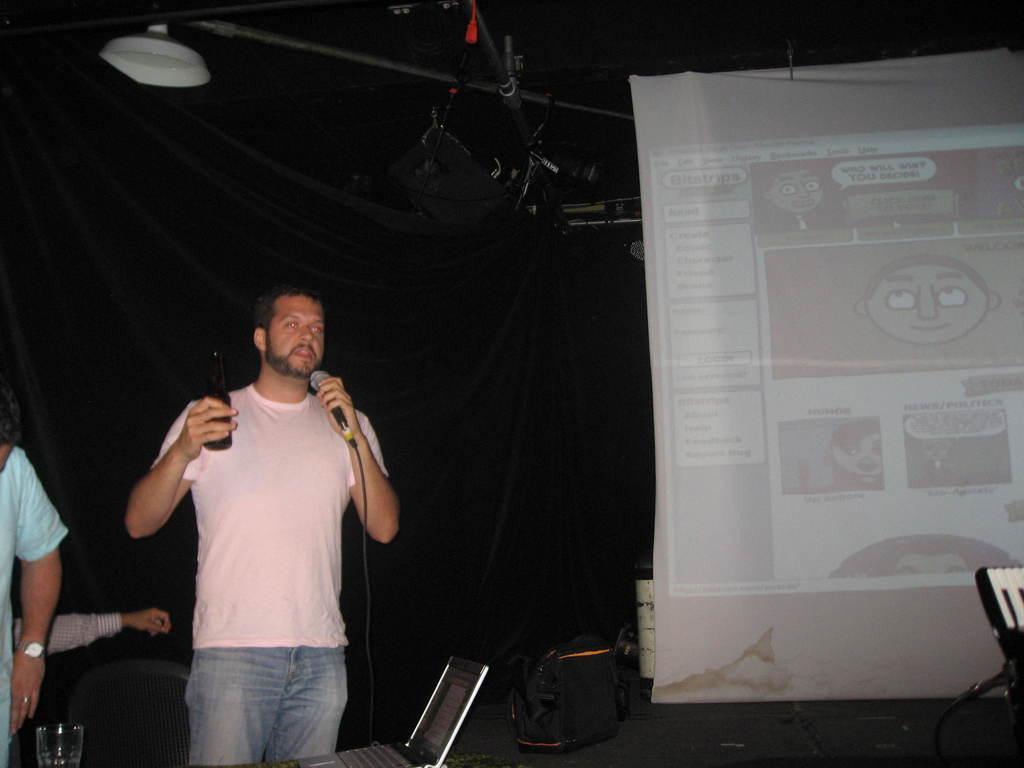Describe this image in one or two sentences. In this image, we can see a man holding mic and a bottle. At the bottom, there is a glass and a laptop. On the right, we can see a chair. In the background, there is a banner and some other people. 